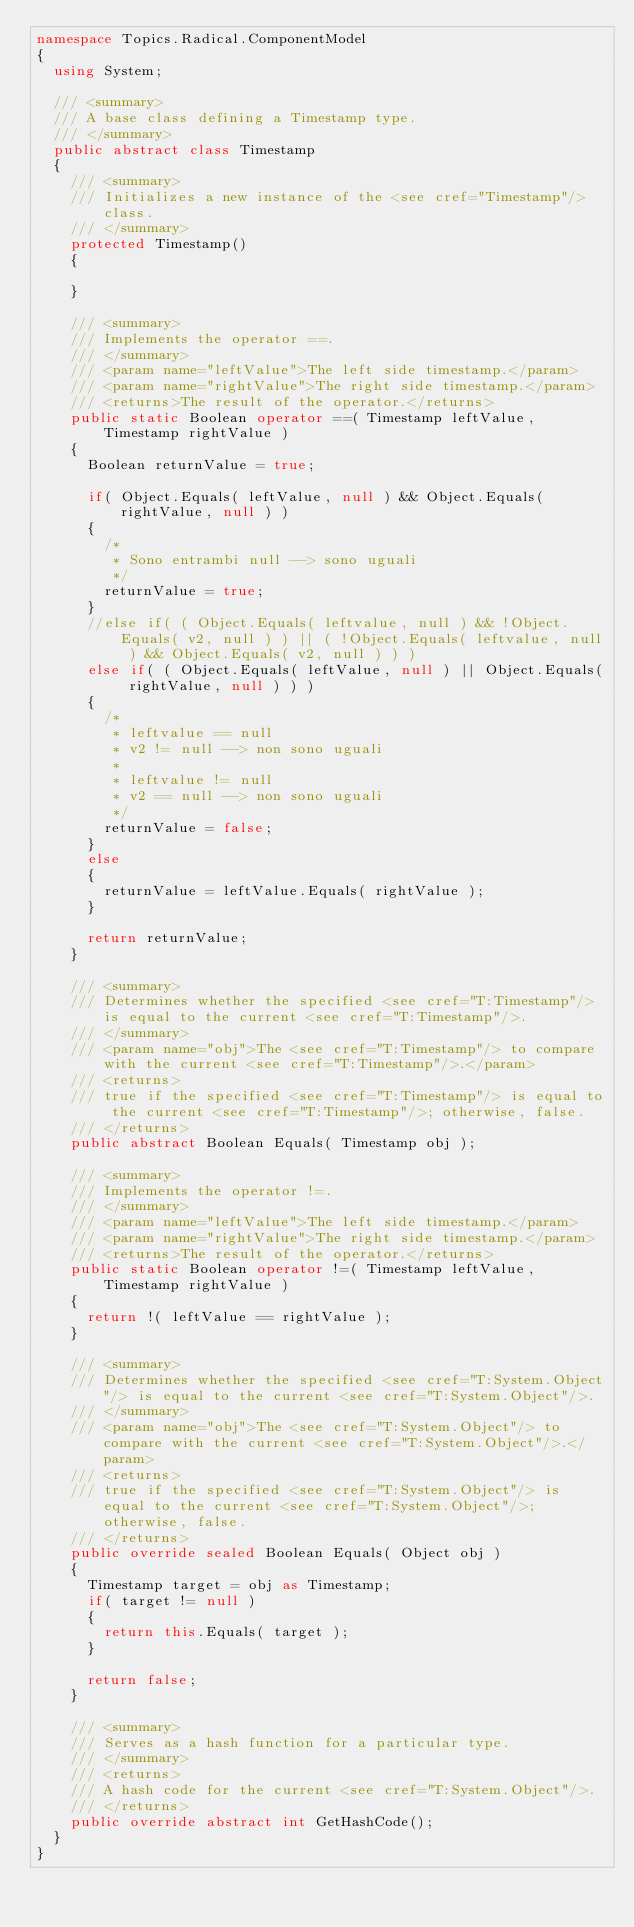Convert code to text. <code><loc_0><loc_0><loc_500><loc_500><_C#_>namespace Topics.Radical.ComponentModel
{
	using System;

	/// <summary>
	/// A base class defining a Timestamp type.
	/// </summary>
	public abstract class Timestamp
	{
		/// <summary>
		/// Initializes a new instance of the <see cref="Timestamp"/> class.
		/// </summary>
		protected Timestamp()
		{

		}

		/// <summary>
		/// Implements the operator ==.
		/// </summary>
		/// <param name="leftValue">The left side timestamp.</param>
		/// <param name="rightValue">The right side timestamp.</param>
		/// <returns>The result of the operator.</returns>
		public static Boolean operator ==( Timestamp leftValue, Timestamp rightValue )
		{
			Boolean returnValue = true;

			if( Object.Equals( leftValue, null ) && Object.Equals( rightValue, null ) )
			{
				/*
				 * Sono entrambi null --> sono uguali
				 */
				returnValue = true;
			}
			//else if( ( Object.Equals( leftvalue, null ) && !Object.Equals( v2, null ) ) || ( !Object.Equals( leftvalue, null ) && Object.Equals( v2, null ) ) )
			else if( ( Object.Equals( leftValue, null ) || Object.Equals( rightValue, null ) ) )
			{
				/*
				 * leftvalue == null
				 * v2 != null --> non sono uguali
				 * 
				 * leftvalue != null
				 * v2 == null --> non sono uguali
				 */
				returnValue = false;
			}
			else
			{
				returnValue = leftValue.Equals( rightValue );
			}

			return returnValue;
		}

		/// <summary>
		/// Determines whether the specified <see cref="T:Timestamp"/> is equal to the current <see cref="T:Timestamp"/>.
		/// </summary>
		/// <param name="obj">The <see cref="T:Timestamp"/> to compare with the current <see cref="T:Timestamp"/>.</param>
		/// <returns>
		/// true if the specified <see cref="T:Timestamp"/> is equal to the current <see cref="T:Timestamp"/>; otherwise, false.
		/// </returns>
		public abstract Boolean Equals( Timestamp obj );

		/// <summary>
		/// Implements the operator !=.
		/// </summary>
		/// <param name="leftValue">The left side timestamp.</param>
		/// <param name="rightValue">The right side timestamp.</param>
		/// <returns>The result of the operator.</returns>
		public static Boolean operator !=( Timestamp leftValue, Timestamp rightValue )
		{
			return !( leftValue == rightValue );
		}

		/// <summary>
		/// Determines whether the specified <see cref="T:System.Object"/> is equal to the current <see cref="T:System.Object"/>.
		/// </summary>
		/// <param name="obj">The <see cref="T:System.Object"/> to compare with the current <see cref="T:System.Object"/>.</param>
		/// <returns>
		/// true if the specified <see cref="T:System.Object"/> is equal to the current <see cref="T:System.Object"/>; otherwise, false.
		/// </returns>
		public override sealed Boolean Equals( Object obj )
		{
			Timestamp target = obj as Timestamp;
			if( target != null )
			{
				return this.Equals( target );
			}

			return false;
		}

		/// <summary>
		/// Serves as a hash function for a particular type.
		/// </summary>
		/// <returns>
		/// A hash code for the current <see cref="T:System.Object"/>.
		/// </returns>
		public override abstract int GetHashCode();
	}
}
</code> 